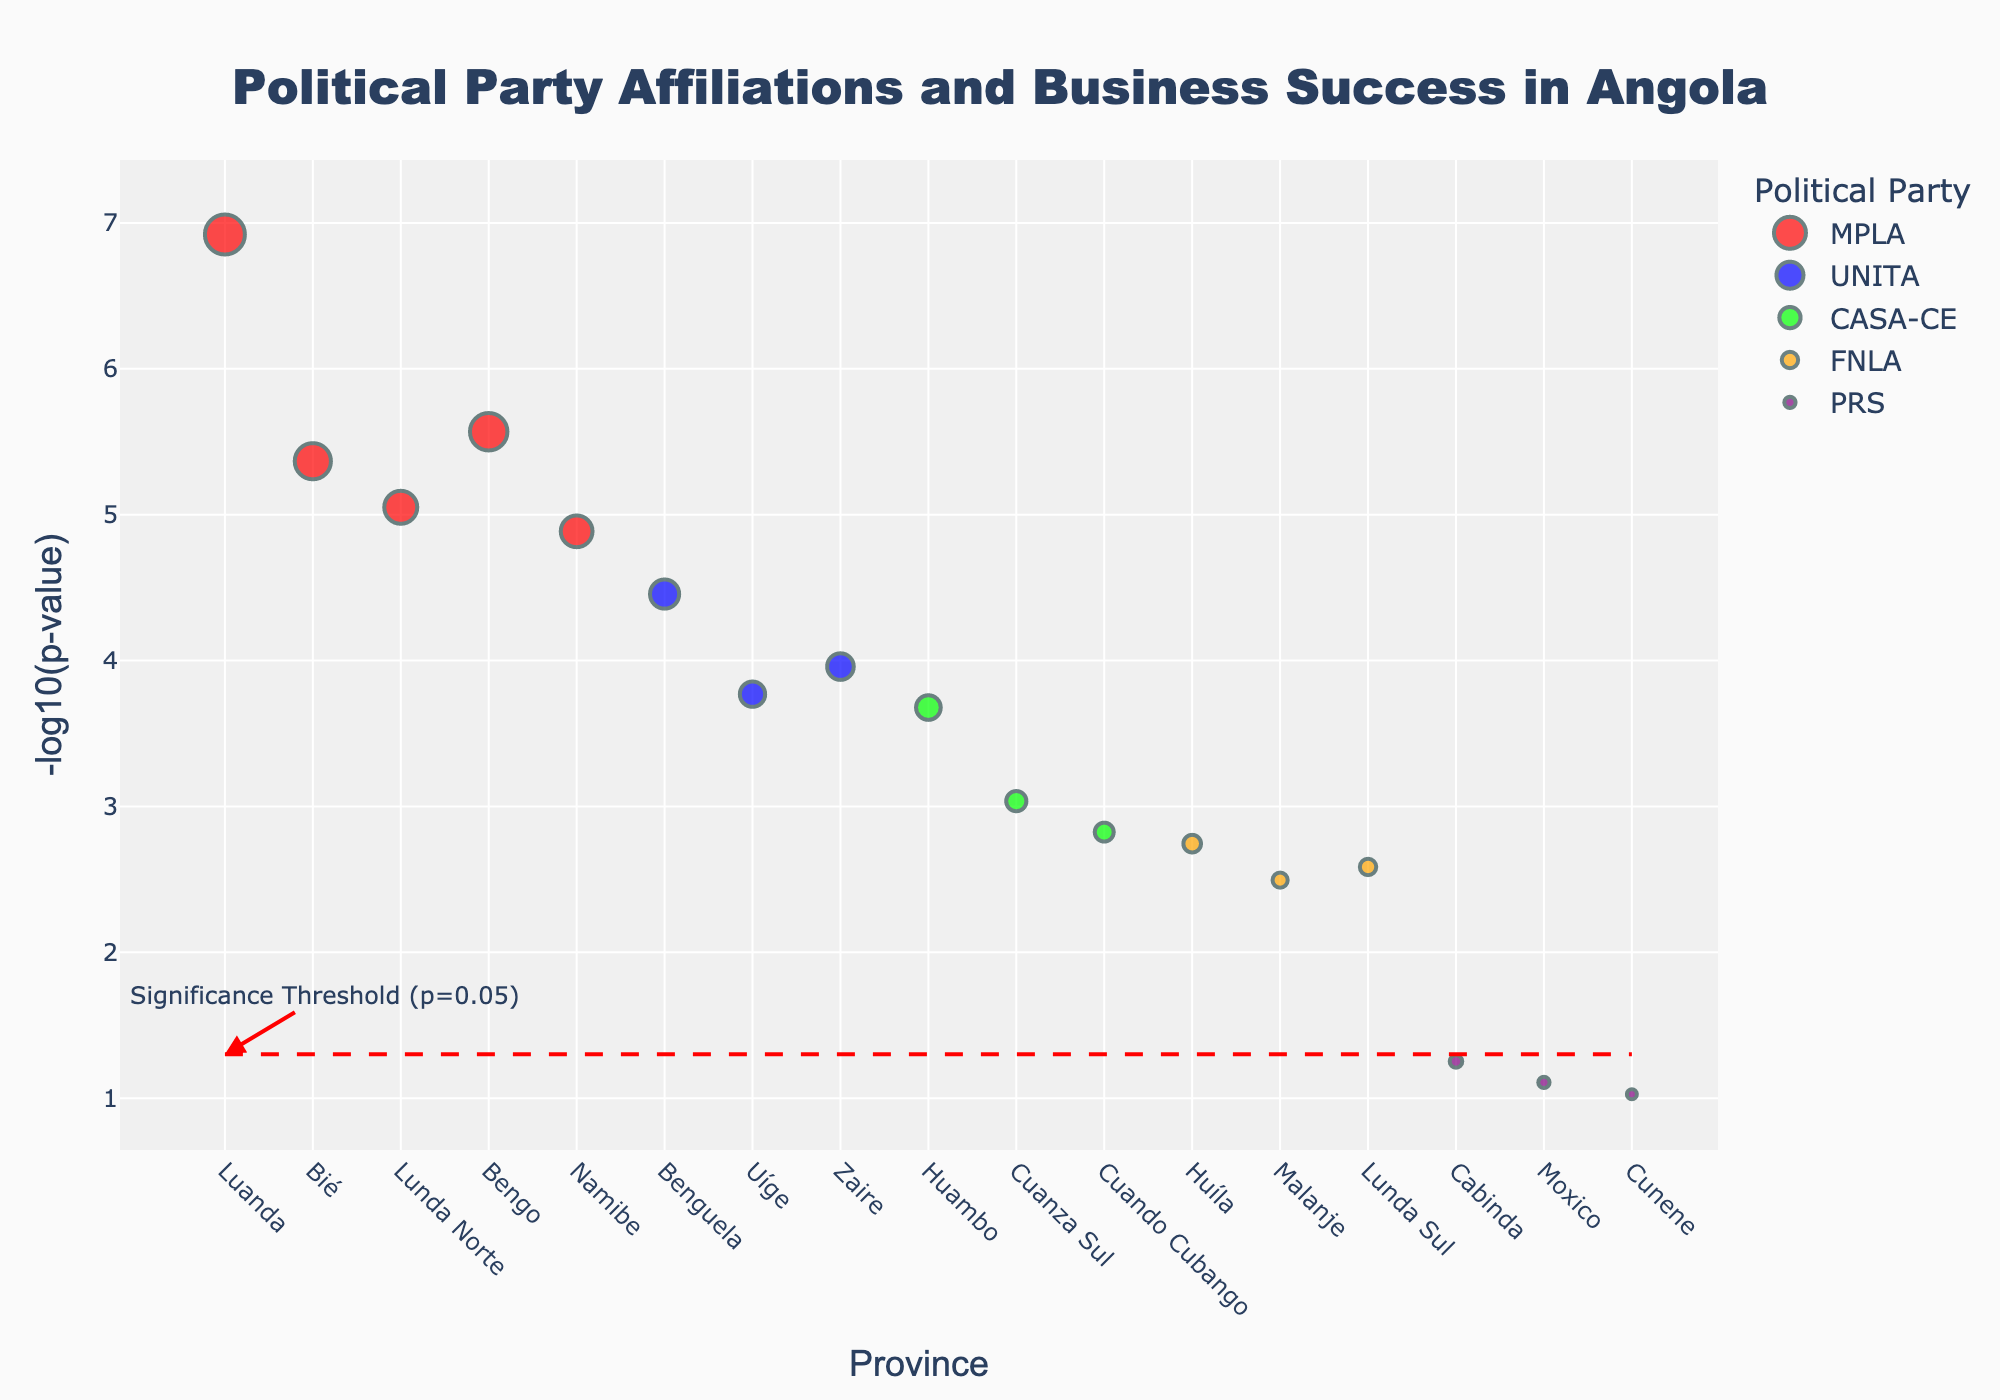What is the title of the plot? The title of the plot is at the top center and it reads "Political Party Affiliations and Business Success in Angola."
Answer: Political Party Affiliations and Business Success in Angola Which political party has the largest marker size in Luanda? Looking at the marker in Luanda, the largest marker is colored red, which corresponds to the MPLA party.
Answer: MPLA How many provinces have marker sizes larger than 10? By inspecting the marker sizes across all provinces, the provinces with sizes larger than 10 are Luanda, Bié, Lunda Norte, Bengo, and Namibe. Thus, there are 5 provinces.
Answer: 5 Which province affiliated with CASA-CE has the highest success score? By comparing the success scores for all provinces affiliated with CASA-CE, the highest score is in Huambo, with a success score of 5.8.
Answer: Huambo How many provinces are affiliated with UNITA? By counting the provinces in the plot with blue markers, there are three provinces: Benguela, Uíge, and Zaire.
Answer: 3 Which province has the highest -log10(p-value)? By looking at the y-axis, the province with the highest -log10(p-value) has the tallest marker, which is Luanda.
Answer: Luanda Are there any provinces with a p-value greater than 0.05? The plot has a horizontal red dashed line marking the significance threshold at -log10(0.05). Markers below this line (i.e., Moxico and Cunene) indicate p-values greater than 0.05.
Answer: Yes Which political party has the least number of significant results (p < 0.05)? FNLA has three provinces (Huíla, Malanje, Lunda Sul), but Moxico has a p-value greater than 0.05, leaving only two significant results. PRS also has three provinces (Cabinda, Moxico, Cunene), but only Cabinda is significant, so PRS has the least with one significant result.
Answer: PRS What is the significance threshold visualized in the plot? The significance threshold is indicated by a horizontal dashed red line. The value of this threshold is -log10(0.05), as also annotated in the plot.
Answer: -log10(0.05) Which political party has the most successful business scores above 6? Observing the markers color-coded for those with success scores greater than 6, MPLA appears most frequently with four provinces: Luanda, Bié, Lunda Norte, and Bengo.
Answer: MPLA 